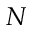Convert formula to latex. <formula><loc_0><loc_0><loc_500><loc_500>N</formula> 